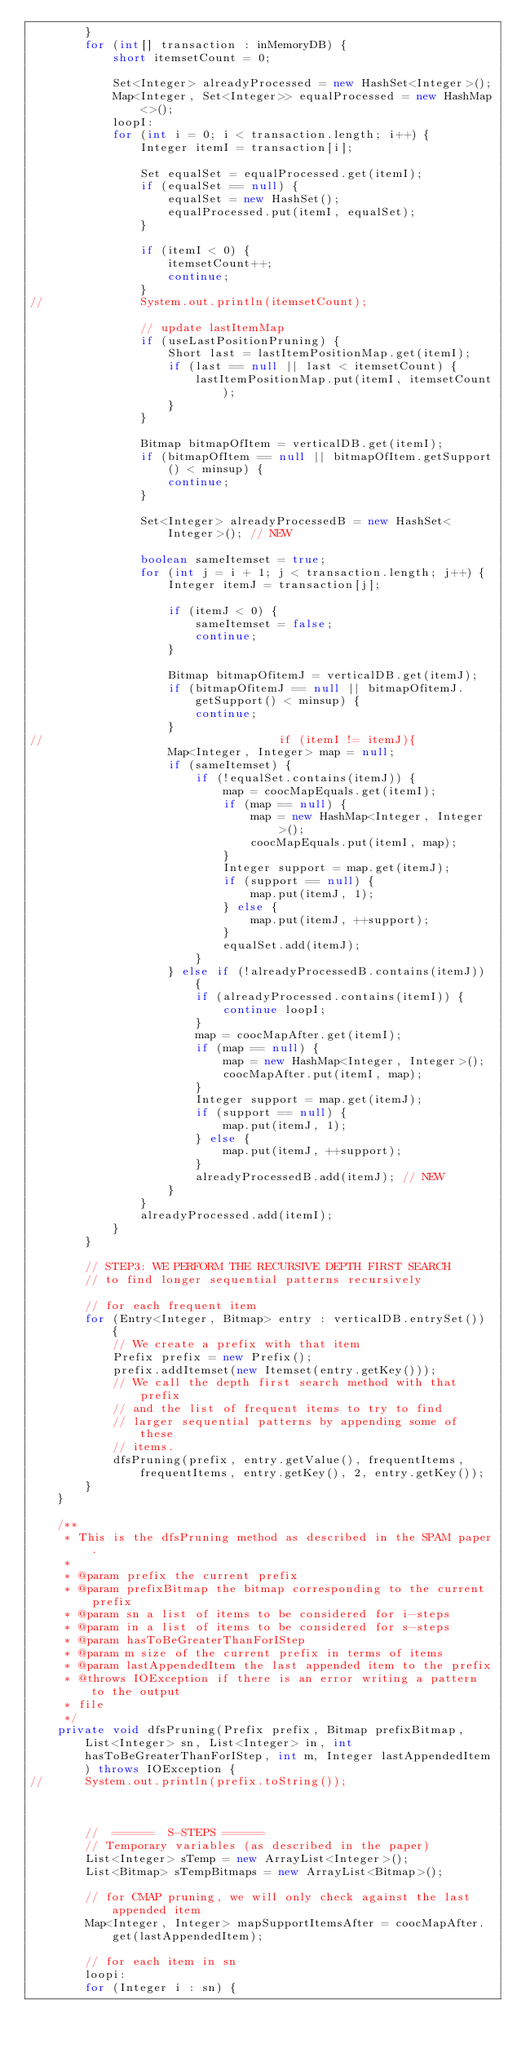<code> <loc_0><loc_0><loc_500><loc_500><_Java_>        }
        for (int[] transaction : inMemoryDB) {
            short itemsetCount = 0;

            Set<Integer> alreadyProcessed = new HashSet<Integer>();
            Map<Integer, Set<Integer>> equalProcessed = new HashMap<>();
            loopI:
            for (int i = 0; i < transaction.length; i++) {
                Integer itemI = transaction[i];

                Set equalSet = equalProcessed.get(itemI);
                if (equalSet == null) {
                    equalSet = new HashSet();
                    equalProcessed.put(itemI, equalSet);
                }

                if (itemI < 0) {
                    itemsetCount++;
                    continue;
                }
//				System.out.println(itemsetCount);

                // update lastItemMap
                if (useLastPositionPruning) {
                    Short last = lastItemPositionMap.get(itemI);
                    if (last == null || last < itemsetCount) {
                        lastItemPositionMap.put(itemI, itemsetCount);
                    }
                }

                Bitmap bitmapOfItem = verticalDB.get(itemI);
                if (bitmapOfItem == null || bitmapOfItem.getSupport() < minsup) {
                    continue;
                }

                Set<Integer> alreadyProcessedB = new HashSet<Integer>(); // NEW

                boolean sameItemset = true;
                for (int j = i + 1; j < transaction.length; j++) {
                    Integer itemJ = transaction[j];

                    if (itemJ < 0) {
                        sameItemset = false;
                        continue;
                    }

                    Bitmap bitmapOfitemJ = verticalDB.get(itemJ);
                    if (bitmapOfitemJ == null || bitmapOfitemJ.getSupport() < minsup) {
                        continue;
                    }
//									if (itemI != itemJ){
                    Map<Integer, Integer> map = null;
                    if (sameItemset) {
                        if (!equalSet.contains(itemJ)) {
                            map = coocMapEquals.get(itemI);
                            if (map == null) {
                                map = new HashMap<Integer, Integer>();
                                coocMapEquals.put(itemI, map);
                            }
                            Integer support = map.get(itemJ);
                            if (support == null) {
                                map.put(itemJ, 1);
                            } else {
                                map.put(itemJ, ++support);
                            }
                            equalSet.add(itemJ);
                        }
                    } else if (!alreadyProcessedB.contains(itemJ)) {
                        if (alreadyProcessed.contains(itemI)) {
                            continue loopI;
                        }
                        map = coocMapAfter.get(itemI);
                        if (map == null) {
                            map = new HashMap<Integer, Integer>();
                            coocMapAfter.put(itemI, map);
                        }
                        Integer support = map.get(itemJ);
                        if (support == null) {
                            map.put(itemJ, 1);
                        } else {
                            map.put(itemJ, ++support);
                        }
                        alreadyProcessedB.add(itemJ); // NEW
                    }
                }
                alreadyProcessed.add(itemI);
            }
        }

        // STEP3: WE PERFORM THE RECURSIVE DEPTH FIRST SEARCH
        // to find longer sequential patterns recursively

        // for each frequent item
        for (Entry<Integer, Bitmap> entry : verticalDB.entrySet()) {
            // We create a prefix with that item
            Prefix prefix = new Prefix();
            prefix.addItemset(new Itemset(entry.getKey()));
            // We call the depth first search method with that prefix
            // and the list of frequent items to try to find
            // larger sequential patterns by appending some of these
            // items.
            dfsPruning(prefix, entry.getValue(), frequentItems, frequentItems, entry.getKey(), 2, entry.getKey());
        }
    }

    /**
     * This is the dfsPruning method as described in the SPAM paper.
     *
     * @param prefix the current prefix
     * @param prefixBitmap the bitmap corresponding to the current prefix
     * @param sn a list of items to be considered for i-steps
     * @param in a list of items to be considered for s-steps
     * @param hasToBeGreaterThanForIStep
     * @param m size of the current prefix in terms of items
     * @param lastAppendedItem the last appended item to the prefix
     * @throws IOException if there is an error writing a pattern to the output
     * file
     */
    private void dfsPruning(Prefix prefix, Bitmap prefixBitmap, List<Integer> sn, List<Integer> in, int hasToBeGreaterThanForIStep, int m, Integer lastAppendedItem) throws IOException {
//		System.out.println(prefix.toString());



        //  ======  S-STEPS ======
        // Temporary variables (as described in the paper)
        List<Integer> sTemp = new ArrayList<Integer>();
        List<Bitmap> sTempBitmaps = new ArrayList<Bitmap>();

        // for CMAP pruning, we will only check against the last appended item
        Map<Integer, Integer> mapSupportItemsAfter = coocMapAfter.get(lastAppendedItem);

        // for each item in sn
        loopi:
        for (Integer i : sn) {
</code> 